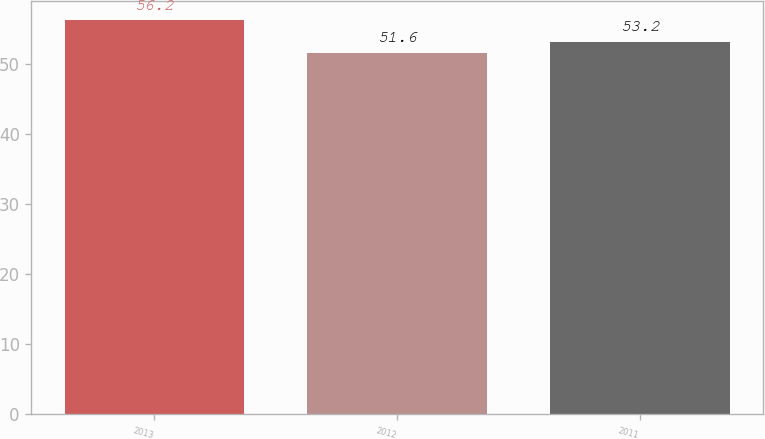Convert chart to OTSL. <chart><loc_0><loc_0><loc_500><loc_500><bar_chart><fcel>2013<fcel>2012<fcel>2011<nl><fcel>56.2<fcel>51.6<fcel>53.2<nl></chart> 